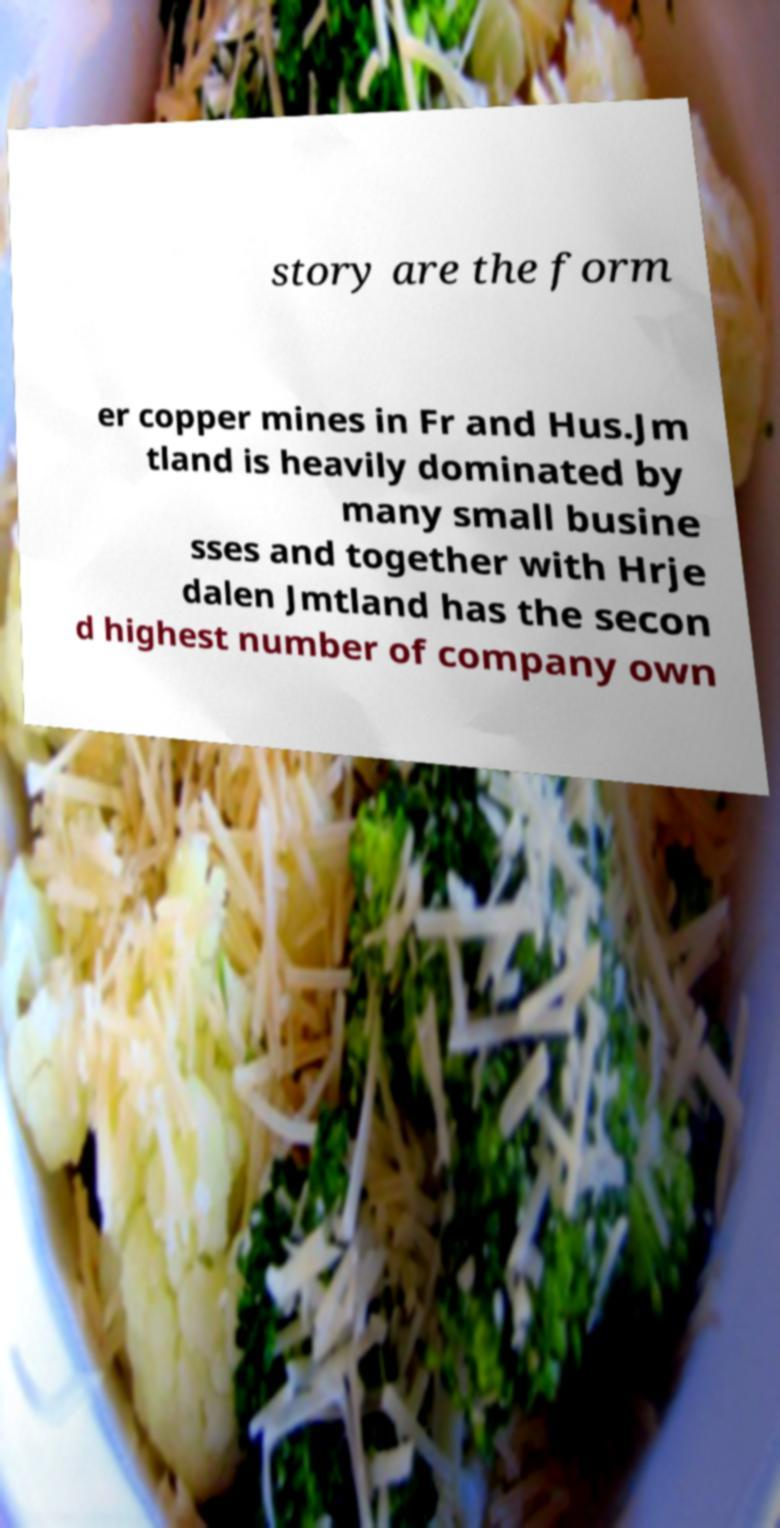Can you accurately transcribe the text from the provided image for me? story are the form er copper mines in Fr and Hus.Jm tland is heavily dominated by many small busine sses and together with Hrje dalen Jmtland has the secon d highest number of company own 